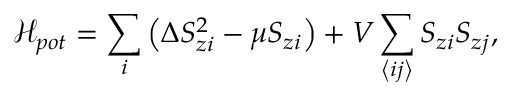Convert formula to latex. <formula><loc_0><loc_0><loc_500><loc_500>\mathcal { H } _ { p o t } = \sum _ { i } \left ( \Delta S _ { z i } ^ { 2 } - \mu S _ { z i } \right ) + V \sum _ { \left \langle i j \right \rangle } S _ { z i } S _ { z j } ,</formula> 